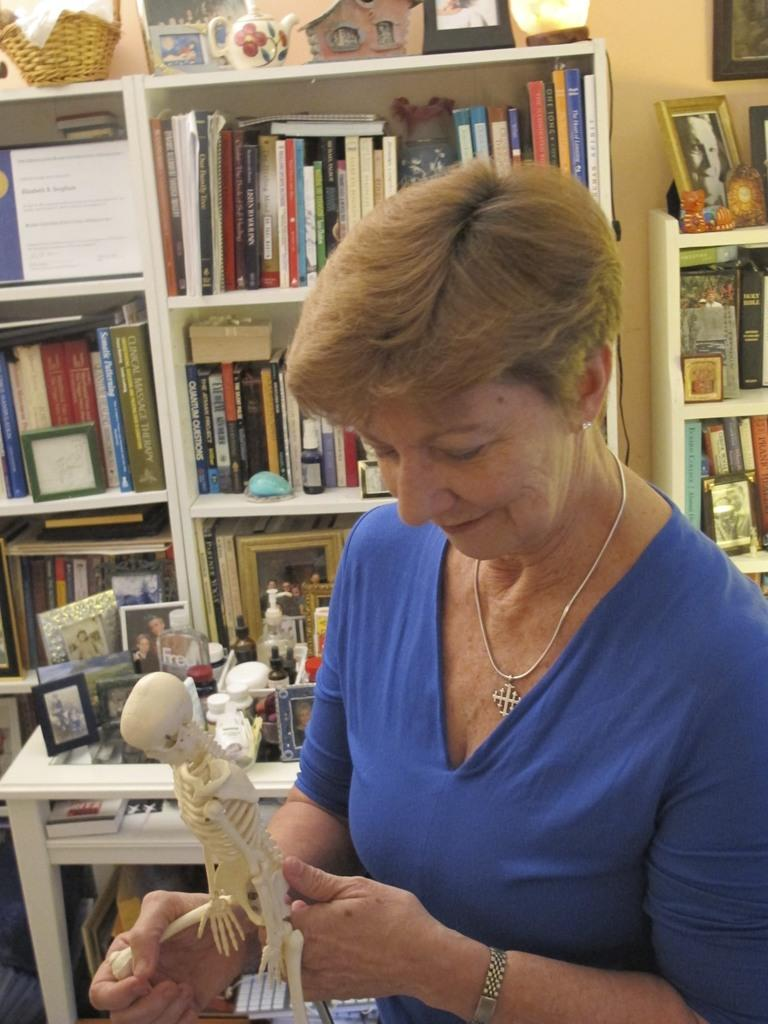Who is present in the image? There is a woman in the image. What is the woman holding in the image? The woman is holding a human skeleton toy. What is the woman's facial expression in the image? The woman is smiling in the image. What color is the woman's t-shirt in the image? The woman is wearing a blue t-shirt in the image. What can be seen in the background of the image? There are books in shelves behind the woman in the image. What type of hot verse is the woman reciting in the image? There is no indication in the image that the woman is reciting any verses, hot or otherwise. 